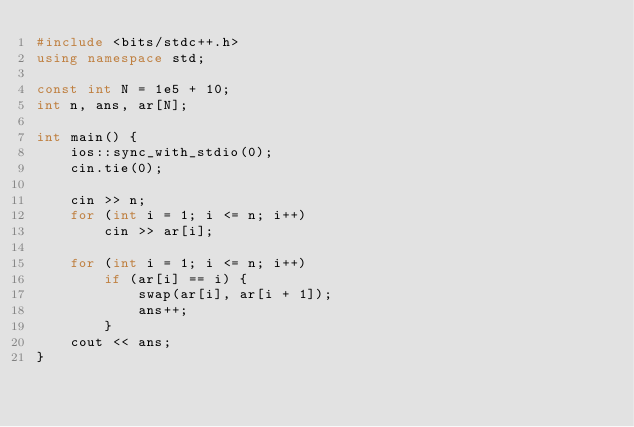<code> <loc_0><loc_0><loc_500><loc_500><_C++_>#include <bits/stdc++.h>
using namespace std;

const int N = 1e5 + 10;
int n, ans, ar[N];

int main() {
	ios::sync_with_stdio(0);
	cin.tie(0);
	
	cin >> n;
	for (int i = 1; i <= n; i++)
		cin >> ar[i];
	
	for (int i = 1; i <= n; i++)
		if (ar[i] == i) {
			swap(ar[i], ar[i + 1]);
			ans++;
		}
	cout << ans;
}</code> 